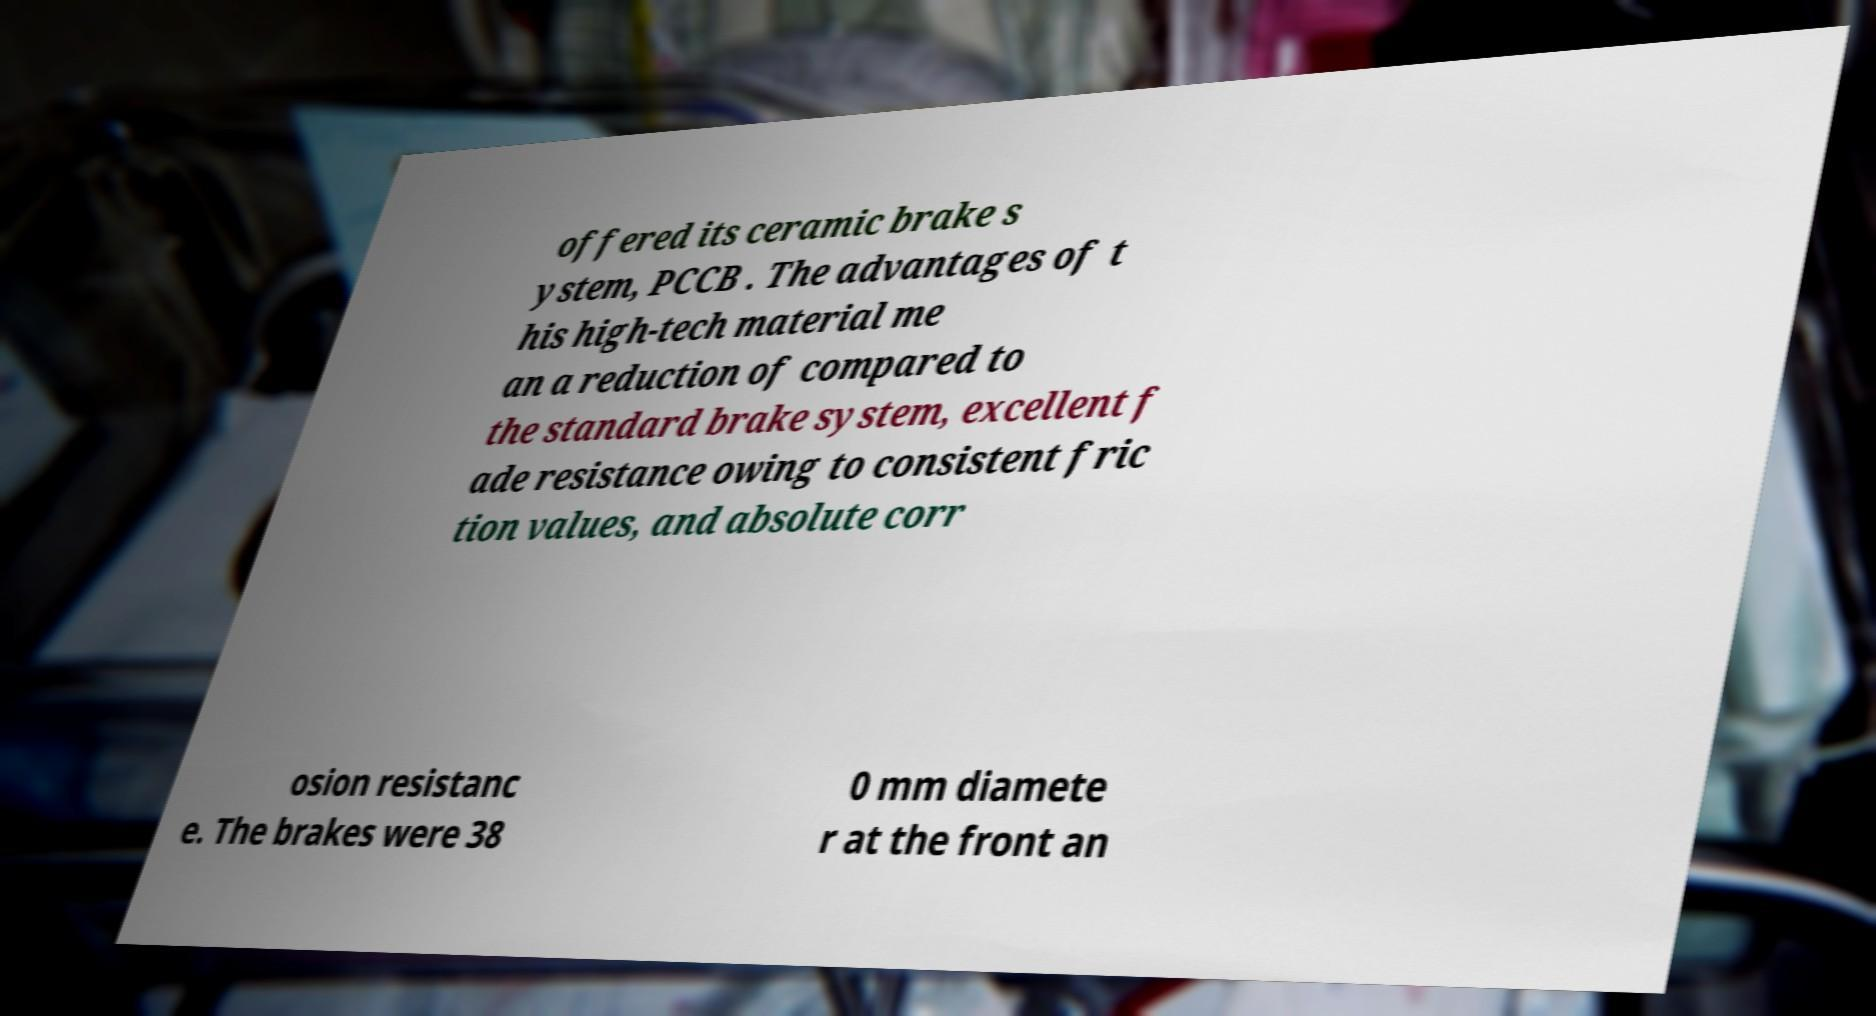Can you accurately transcribe the text from the provided image for me? offered its ceramic brake s ystem, PCCB . The advantages of t his high-tech material me an a reduction of compared to the standard brake system, excellent f ade resistance owing to consistent fric tion values, and absolute corr osion resistanc e. The brakes were 38 0 mm diamete r at the front an 